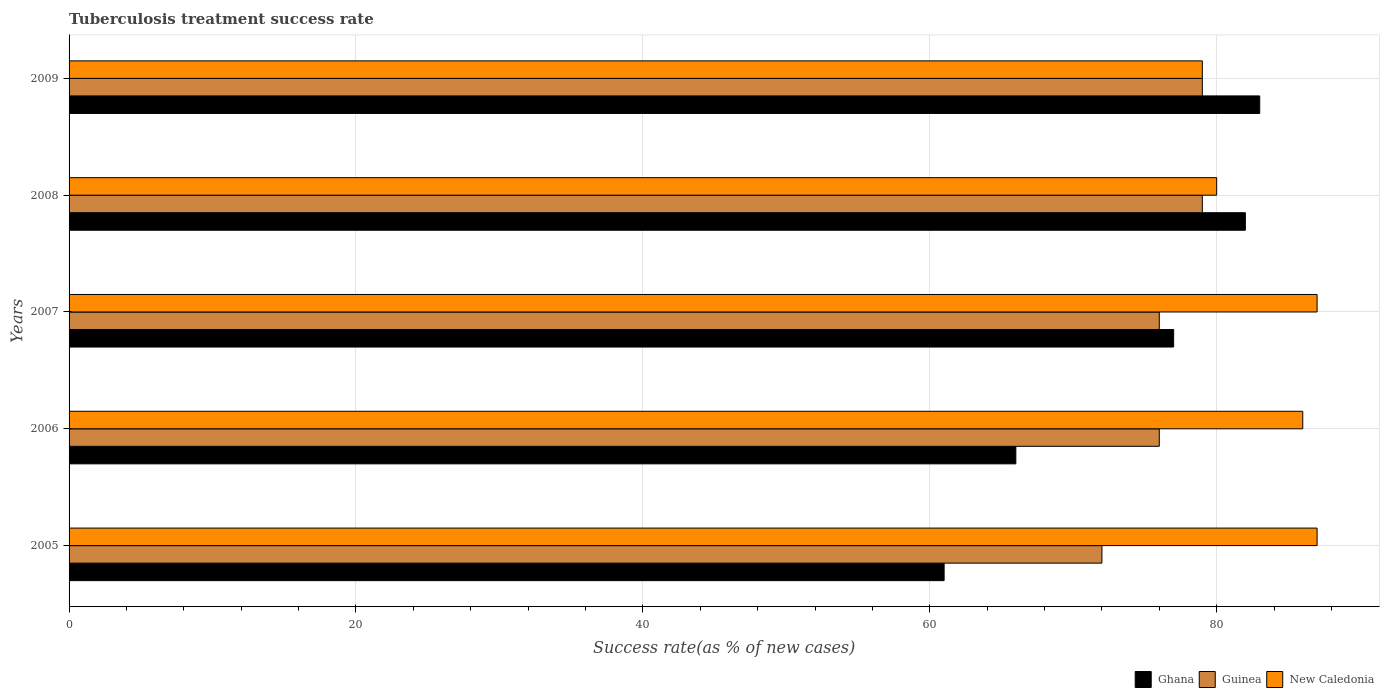How many groups of bars are there?
Give a very brief answer. 5. Are the number of bars per tick equal to the number of legend labels?
Provide a short and direct response. Yes. How many bars are there on the 4th tick from the top?
Your answer should be compact. 3. How many bars are there on the 5th tick from the bottom?
Your answer should be compact. 3. What is the tuberculosis treatment success rate in Guinea in 2009?
Give a very brief answer. 79. What is the total tuberculosis treatment success rate in New Caledonia in the graph?
Keep it short and to the point. 419. What is the difference between the tuberculosis treatment success rate in Guinea in 2006 and that in 2008?
Give a very brief answer. -3. What is the difference between the tuberculosis treatment success rate in New Caledonia in 2005 and the tuberculosis treatment success rate in Ghana in 2007?
Your response must be concise. 10. What is the average tuberculosis treatment success rate in Ghana per year?
Your response must be concise. 73.8. In the year 2009, what is the difference between the tuberculosis treatment success rate in New Caledonia and tuberculosis treatment success rate in Ghana?
Offer a very short reply. -4. In how many years, is the tuberculosis treatment success rate in Ghana greater than 28 %?
Give a very brief answer. 5. What is the ratio of the tuberculosis treatment success rate in Guinea in 2005 to that in 2009?
Give a very brief answer. 0.91. What is the difference between the highest and the lowest tuberculosis treatment success rate in New Caledonia?
Offer a terse response. 8. Is the sum of the tuberculosis treatment success rate in Guinea in 2008 and 2009 greater than the maximum tuberculosis treatment success rate in New Caledonia across all years?
Provide a short and direct response. Yes. What does the 2nd bar from the top in 2007 represents?
Your answer should be compact. Guinea. What does the 3rd bar from the bottom in 2009 represents?
Offer a terse response. New Caledonia. Is it the case that in every year, the sum of the tuberculosis treatment success rate in Ghana and tuberculosis treatment success rate in Guinea is greater than the tuberculosis treatment success rate in New Caledonia?
Offer a terse response. Yes. How many bars are there?
Ensure brevity in your answer.  15. Are all the bars in the graph horizontal?
Offer a terse response. Yes. Are the values on the major ticks of X-axis written in scientific E-notation?
Provide a succinct answer. No. Does the graph contain grids?
Ensure brevity in your answer.  Yes. Where does the legend appear in the graph?
Offer a terse response. Bottom right. How many legend labels are there?
Keep it short and to the point. 3. What is the title of the graph?
Keep it short and to the point. Tuberculosis treatment success rate. Does "Hungary" appear as one of the legend labels in the graph?
Provide a short and direct response. No. What is the label or title of the X-axis?
Your answer should be very brief. Success rate(as % of new cases). What is the label or title of the Y-axis?
Your answer should be compact. Years. What is the Success rate(as % of new cases) in New Caledonia in 2005?
Offer a very short reply. 87. What is the Success rate(as % of new cases) of Guinea in 2007?
Your answer should be compact. 76. What is the Success rate(as % of new cases) of New Caledonia in 2007?
Provide a short and direct response. 87. What is the Success rate(as % of new cases) in Guinea in 2008?
Make the answer very short. 79. What is the Success rate(as % of new cases) of Guinea in 2009?
Provide a succinct answer. 79. What is the Success rate(as % of new cases) of New Caledonia in 2009?
Your answer should be very brief. 79. Across all years, what is the maximum Success rate(as % of new cases) of Ghana?
Keep it short and to the point. 83. Across all years, what is the maximum Success rate(as % of new cases) of Guinea?
Offer a very short reply. 79. Across all years, what is the maximum Success rate(as % of new cases) in New Caledonia?
Your response must be concise. 87. Across all years, what is the minimum Success rate(as % of new cases) of Guinea?
Your answer should be compact. 72. Across all years, what is the minimum Success rate(as % of new cases) of New Caledonia?
Your response must be concise. 79. What is the total Success rate(as % of new cases) in Ghana in the graph?
Your answer should be very brief. 369. What is the total Success rate(as % of new cases) of Guinea in the graph?
Give a very brief answer. 382. What is the total Success rate(as % of new cases) of New Caledonia in the graph?
Offer a terse response. 419. What is the difference between the Success rate(as % of new cases) in Ghana in 2005 and that in 2006?
Make the answer very short. -5. What is the difference between the Success rate(as % of new cases) in New Caledonia in 2005 and that in 2006?
Keep it short and to the point. 1. What is the difference between the Success rate(as % of new cases) of Guinea in 2005 and that in 2007?
Your answer should be compact. -4. What is the difference between the Success rate(as % of new cases) of New Caledonia in 2005 and that in 2007?
Ensure brevity in your answer.  0. What is the difference between the Success rate(as % of new cases) of New Caledonia in 2005 and that in 2008?
Your response must be concise. 7. What is the difference between the Success rate(as % of new cases) of Ghana in 2005 and that in 2009?
Make the answer very short. -22. What is the difference between the Success rate(as % of new cases) of Guinea in 2005 and that in 2009?
Keep it short and to the point. -7. What is the difference between the Success rate(as % of new cases) in New Caledonia in 2005 and that in 2009?
Ensure brevity in your answer.  8. What is the difference between the Success rate(as % of new cases) in Guinea in 2006 and that in 2007?
Your response must be concise. 0. What is the difference between the Success rate(as % of new cases) of Guinea in 2006 and that in 2009?
Make the answer very short. -3. What is the difference between the Success rate(as % of new cases) in Ghana in 2007 and that in 2008?
Your response must be concise. -5. What is the difference between the Success rate(as % of new cases) of Guinea in 2007 and that in 2008?
Provide a succinct answer. -3. What is the difference between the Success rate(as % of new cases) of New Caledonia in 2007 and that in 2008?
Offer a terse response. 7. What is the difference between the Success rate(as % of new cases) of Ghana in 2007 and that in 2009?
Ensure brevity in your answer.  -6. What is the difference between the Success rate(as % of new cases) of Ghana in 2008 and that in 2009?
Provide a succinct answer. -1. What is the difference between the Success rate(as % of new cases) of New Caledonia in 2008 and that in 2009?
Keep it short and to the point. 1. What is the difference between the Success rate(as % of new cases) in Ghana in 2005 and the Success rate(as % of new cases) in New Caledonia in 2006?
Your answer should be very brief. -25. What is the difference between the Success rate(as % of new cases) in Guinea in 2005 and the Success rate(as % of new cases) in New Caledonia in 2006?
Provide a succinct answer. -14. What is the difference between the Success rate(as % of new cases) in Ghana in 2005 and the Success rate(as % of new cases) in Guinea in 2007?
Keep it short and to the point. -15. What is the difference between the Success rate(as % of new cases) in Ghana in 2005 and the Success rate(as % of new cases) in New Caledonia in 2007?
Offer a terse response. -26. What is the difference between the Success rate(as % of new cases) of Guinea in 2005 and the Success rate(as % of new cases) of New Caledonia in 2007?
Your answer should be very brief. -15. What is the difference between the Success rate(as % of new cases) of Ghana in 2005 and the Success rate(as % of new cases) of Guinea in 2008?
Your answer should be very brief. -18. What is the difference between the Success rate(as % of new cases) of Ghana in 2005 and the Success rate(as % of new cases) of New Caledonia in 2008?
Your answer should be very brief. -19. What is the difference between the Success rate(as % of new cases) in Ghana in 2005 and the Success rate(as % of new cases) in Guinea in 2009?
Offer a very short reply. -18. What is the difference between the Success rate(as % of new cases) in Ghana in 2005 and the Success rate(as % of new cases) in New Caledonia in 2009?
Keep it short and to the point. -18. What is the difference between the Success rate(as % of new cases) in Ghana in 2006 and the Success rate(as % of new cases) in Guinea in 2007?
Offer a terse response. -10. What is the difference between the Success rate(as % of new cases) of Ghana in 2006 and the Success rate(as % of new cases) of New Caledonia in 2007?
Offer a very short reply. -21. What is the difference between the Success rate(as % of new cases) of Ghana in 2006 and the Success rate(as % of new cases) of New Caledonia in 2008?
Provide a succinct answer. -14. What is the difference between the Success rate(as % of new cases) in Guinea in 2006 and the Success rate(as % of new cases) in New Caledonia in 2008?
Keep it short and to the point. -4. What is the difference between the Success rate(as % of new cases) of Ghana in 2006 and the Success rate(as % of new cases) of New Caledonia in 2009?
Provide a short and direct response. -13. What is the difference between the Success rate(as % of new cases) of Ghana in 2007 and the Success rate(as % of new cases) of New Caledonia in 2008?
Your answer should be very brief. -3. What is the difference between the Success rate(as % of new cases) in Guinea in 2007 and the Success rate(as % of new cases) in New Caledonia in 2008?
Provide a short and direct response. -4. What is the difference between the Success rate(as % of new cases) in Ghana in 2007 and the Success rate(as % of new cases) in Guinea in 2009?
Ensure brevity in your answer.  -2. What is the difference between the Success rate(as % of new cases) in Ghana in 2007 and the Success rate(as % of new cases) in New Caledonia in 2009?
Give a very brief answer. -2. What is the difference between the Success rate(as % of new cases) of Guinea in 2007 and the Success rate(as % of new cases) of New Caledonia in 2009?
Provide a short and direct response. -3. What is the difference between the Success rate(as % of new cases) of Ghana in 2008 and the Success rate(as % of new cases) of Guinea in 2009?
Make the answer very short. 3. What is the difference between the Success rate(as % of new cases) of Guinea in 2008 and the Success rate(as % of new cases) of New Caledonia in 2009?
Your answer should be compact. 0. What is the average Success rate(as % of new cases) of Ghana per year?
Offer a very short reply. 73.8. What is the average Success rate(as % of new cases) in Guinea per year?
Make the answer very short. 76.4. What is the average Success rate(as % of new cases) in New Caledonia per year?
Your response must be concise. 83.8. In the year 2005, what is the difference between the Success rate(as % of new cases) of Ghana and Success rate(as % of new cases) of Guinea?
Give a very brief answer. -11. In the year 2006, what is the difference between the Success rate(as % of new cases) of Ghana and Success rate(as % of new cases) of New Caledonia?
Provide a short and direct response. -20. In the year 2007, what is the difference between the Success rate(as % of new cases) in Ghana and Success rate(as % of new cases) in New Caledonia?
Provide a succinct answer. -10. In the year 2008, what is the difference between the Success rate(as % of new cases) in Ghana and Success rate(as % of new cases) in Guinea?
Your answer should be compact. 3. In the year 2009, what is the difference between the Success rate(as % of new cases) in Ghana and Success rate(as % of new cases) in Guinea?
Your response must be concise. 4. In the year 2009, what is the difference between the Success rate(as % of new cases) in Guinea and Success rate(as % of new cases) in New Caledonia?
Make the answer very short. 0. What is the ratio of the Success rate(as % of new cases) of Ghana in 2005 to that in 2006?
Provide a short and direct response. 0.92. What is the ratio of the Success rate(as % of new cases) in New Caledonia in 2005 to that in 2006?
Your answer should be very brief. 1.01. What is the ratio of the Success rate(as % of new cases) of Ghana in 2005 to that in 2007?
Your answer should be very brief. 0.79. What is the ratio of the Success rate(as % of new cases) in Guinea in 2005 to that in 2007?
Provide a succinct answer. 0.95. What is the ratio of the Success rate(as % of new cases) of New Caledonia in 2005 to that in 2007?
Ensure brevity in your answer.  1. What is the ratio of the Success rate(as % of new cases) of Ghana in 2005 to that in 2008?
Your response must be concise. 0.74. What is the ratio of the Success rate(as % of new cases) of Guinea in 2005 to that in 2008?
Make the answer very short. 0.91. What is the ratio of the Success rate(as % of new cases) in New Caledonia in 2005 to that in 2008?
Offer a terse response. 1.09. What is the ratio of the Success rate(as % of new cases) in Ghana in 2005 to that in 2009?
Your answer should be very brief. 0.73. What is the ratio of the Success rate(as % of new cases) in Guinea in 2005 to that in 2009?
Your response must be concise. 0.91. What is the ratio of the Success rate(as % of new cases) of New Caledonia in 2005 to that in 2009?
Offer a very short reply. 1.1. What is the ratio of the Success rate(as % of new cases) in Ghana in 2006 to that in 2007?
Offer a very short reply. 0.86. What is the ratio of the Success rate(as % of new cases) of New Caledonia in 2006 to that in 2007?
Give a very brief answer. 0.99. What is the ratio of the Success rate(as % of new cases) in Ghana in 2006 to that in 2008?
Provide a succinct answer. 0.8. What is the ratio of the Success rate(as % of new cases) in New Caledonia in 2006 to that in 2008?
Your answer should be compact. 1.07. What is the ratio of the Success rate(as % of new cases) in Ghana in 2006 to that in 2009?
Your answer should be very brief. 0.8. What is the ratio of the Success rate(as % of new cases) in Guinea in 2006 to that in 2009?
Offer a very short reply. 0.96. What is the ratio of the Success rate(as % of new cases) in New Caledonia in 2006 to that in 2009?
Give a very brief answer. 1.09. What is the ratio of the Success rate(as % of new cases) of Ghana in 2007 to that in 2008?
Provide a succinct answer. 0.94. What is the ratio of the Success rate(as % of new cases) in New Caledonia in 2007 to that in 2008?
Ensure brevity in your answer.  1.09. What is the ratio of the Success rate(as % of new cases) in Ghana in 2007 to that in 2009?
Provide a short and direct response. 0.93. What is the ratio of the Success rate(as % of new cases) of Guinea in 2007 to that in 2009?
Offer a terse response. 0.96. What is the ratio of the Success rate(as % of new cases) in New Caledonia in 2007 to that in 2009?
Give a very brief answer. 1.1. What is the ratio of the Success rate(as % of new cases) in Guinea in 2008 to that in 2009?
Make the answer very short. 1. What is the ratio of the Success rate(as % of new cases) of New Caledonia in 2008 to that in 2009?
Your answer should be very brief. 1.01. What is the difference between the highest and the second highest Success rate(as % of new cases) of Ghana?
Provide a short and direct response. 1. What is the difference between the highest and the second highest Success rate(as % of new cases) of Guinea?
Offer a terse response. 0. What is the difference between the highest and the second highest Success rate(as % of new cases) in New Caledonia?
Keep it short and to the point. 0. What is the difference between the highest and the lowest Success rate(as % of new cases) in New Caledonia?
Provide a short and direct response. 8. 